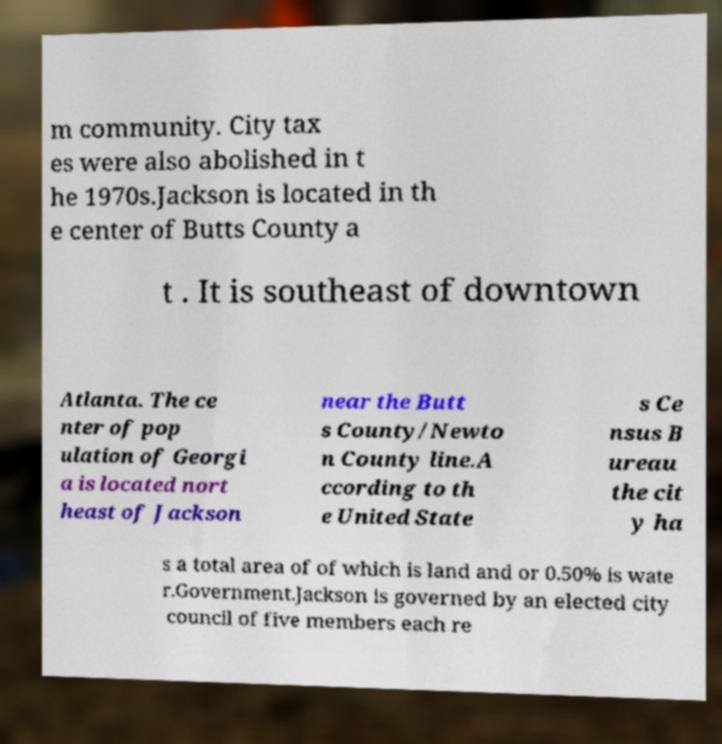What messages or text are displayed in this image? I need them in a readable, typed format. m community. City tax es were also abolished in t he 1970s.Jackson is located in th e center of Butts County a t . It is southeast of downtown Atlanta. The ce nter of pop ulation of Georgi a is located nort heast of Jackson near the Butt s County/Newto n County line.A ccording to th e United State s Ce nsus B ureau the cit y ha s a total area of of which is land and or 0.50% is wate r.Government.Jackson is governed by an elected city council of five members each re 